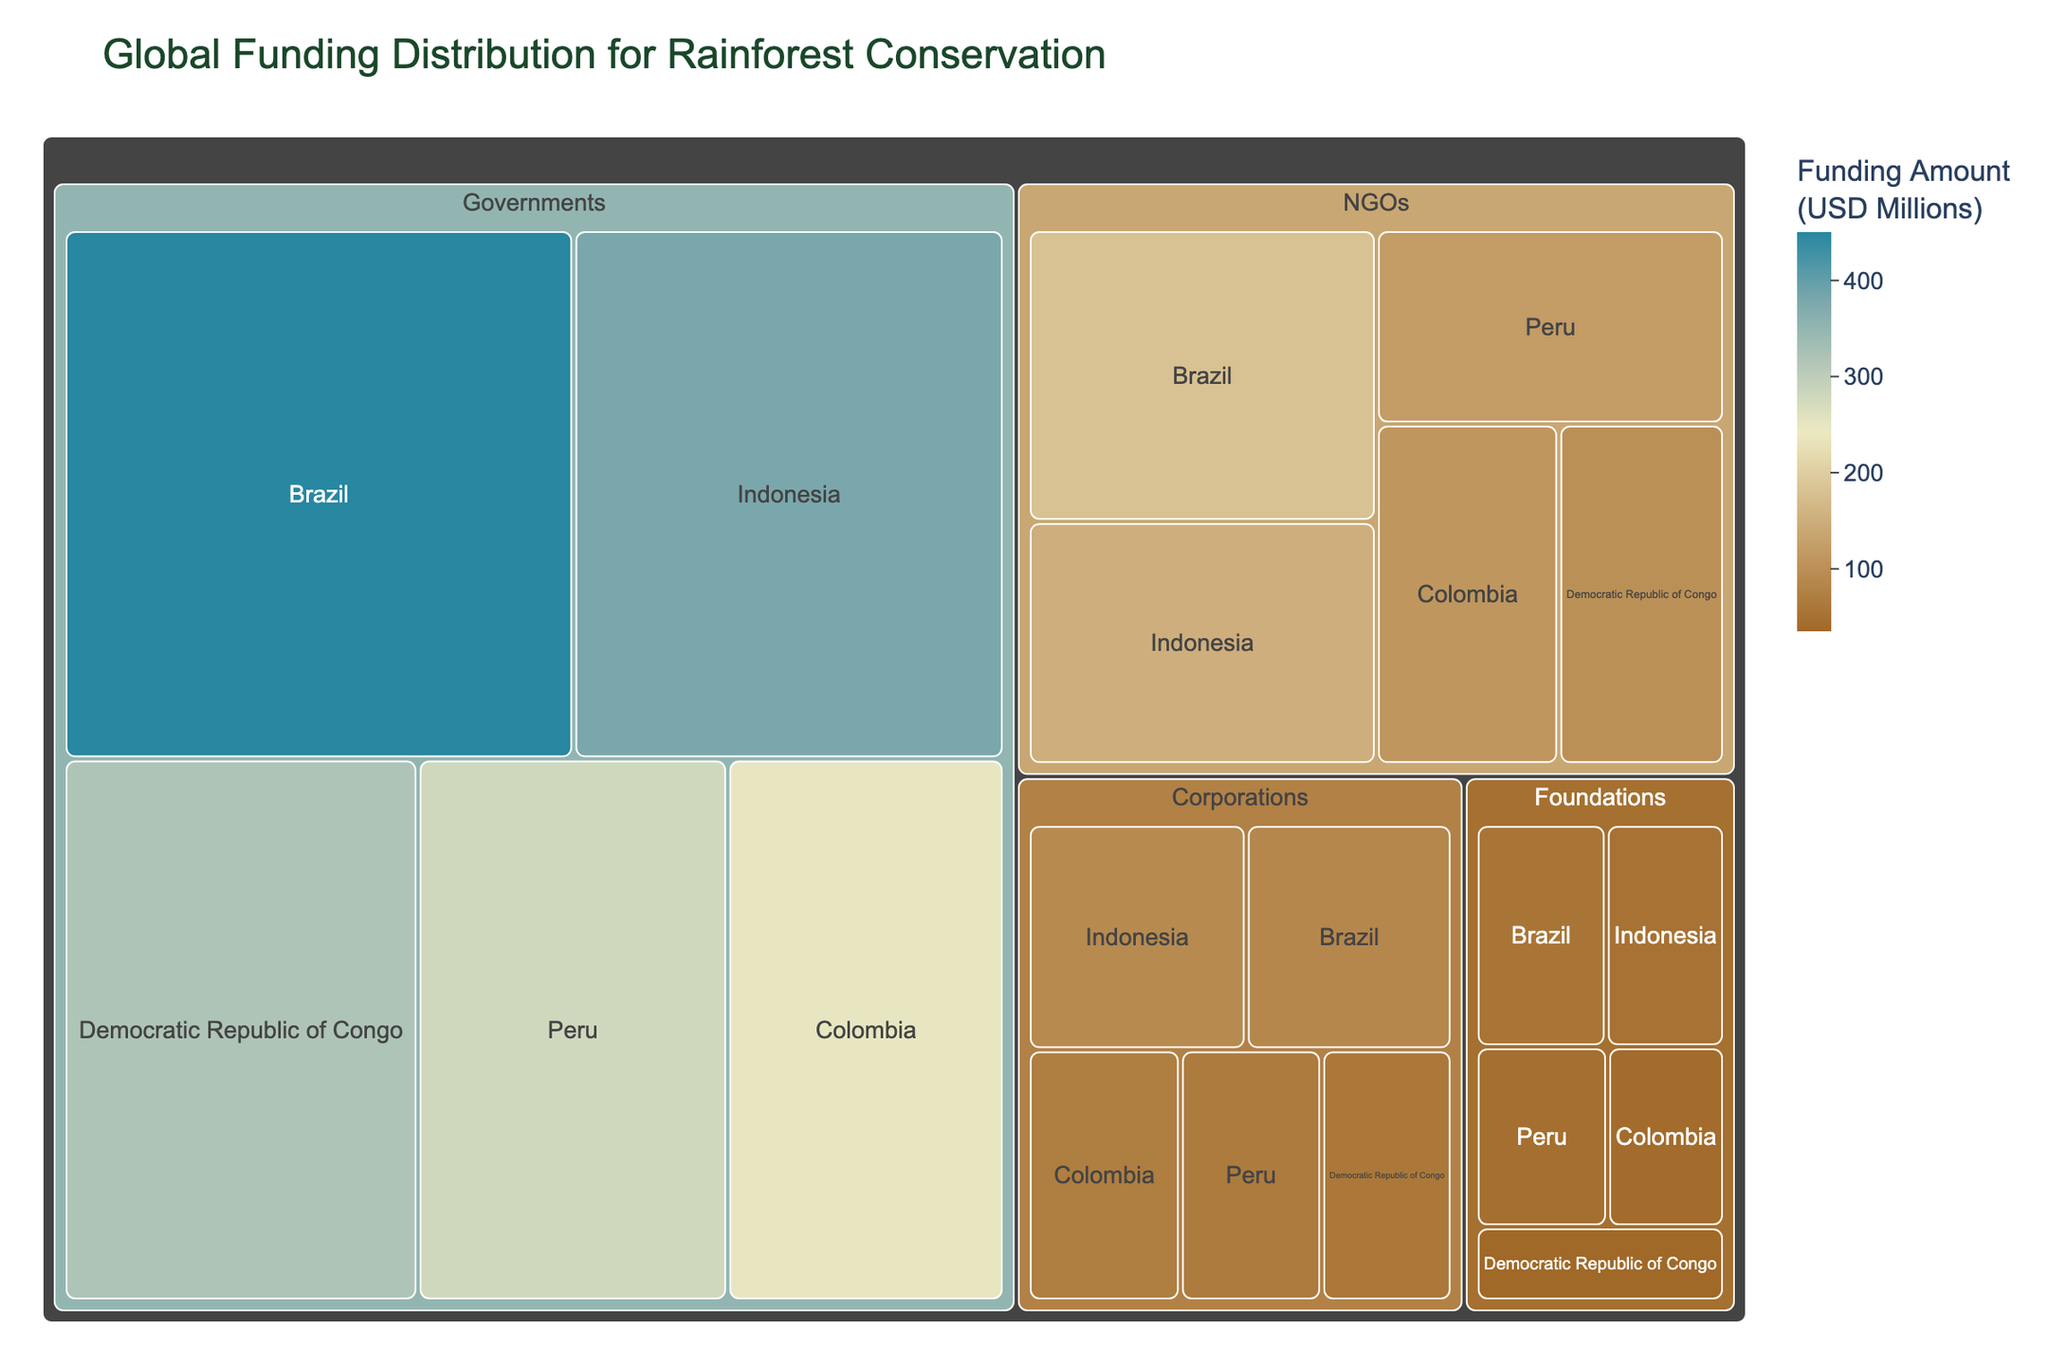What is the total funding amount from corporations? To find the total funding amount from corporations, sum the funding amounts for Indonesia, Brazil, Colombia, Peru, and the Democratic Republic of Congo. Thus, 90 + 85 + 70 + 65 + 60 = 370 million USD.
Answer: 370 million USD Which country received the highest total funding? Compare the sum of funding amounts for each country. Brazil's total is 450 + 180 + 85 + 55 = 770 million USD, Indonesia's total is 380 + 150 + 90 + 50 = 670 million USD, Democratic Republic of Congo's total is 320 + 100 + 60 + 35 = 515 million USD, Peru's total is 280 + 120 + 65 + 45 = 510 million USD, and Colombia's total is 250 + 110 + 70 + 40 = 470 million USD.
Answer: Brazil How much more funding did governments provide compared to NGOs? Sum the funding amounts for governments (450 + 380 + 320 + 280 + 250 = 1680 million USD) and NGOs (180 + 150 + 120 + 110 + 100 = 660 million USD). The difference is 1680 - 660 = 1020 million USD.
Answer: 1020 million USD Which donor type contributed the least amount of funding to the Democratic Republic of Congo? Look at the funding amounts contributed by each donor type to the Democratic Republic of Congo: Governments (320 million USD), NGOs (100 million USD), Corporations (60 million USD), and Foundations (35 million USD). The least amount is by Foundations.
Answer: Foundations What is the average funding amount provided by NGOs across all countries? Sum the funding amounts provided by NGOs (180 + 150 + 120 + 110 + 100 = 660 million USD) and divide by the number of countries (5). The average is 660 / 5 = 132 million USD.
Answer: 132 million USD Which donor type has the most diverse distribution of funding amounts across countries? To determine the most diverse distribution, compare the range of funding amounts (difference between highest and lowest amounts) for each donor type: Governments (450 - 250 = 200 million USD), NGOs (180 - 100 = 80 million USD), Corporations (90 - 60 = 30 million USD), and Foundations (55 - 35 = 20 million USD). The most diverse distribution is by Governments.
Answer: Governments How much funding did foundations provide to all countries combined? Sum the funding amounts provided by foundations to each country: 55 + 50 + 45 + 40 + 35 = 225 million USD.
Answer: 225 million USD Which country received the least funding from foundations? Look at the funding amounts provided by foundations to each country: Brazil (55 million USD), Indonesia (50 million USD), Peru (45 million USD), Colombia (40 million USD), and Democratic Republic of Congo (35 million USD). The least amount is for the Democratic Republic of Congo.
Answer: Democratic Republic of Congo 